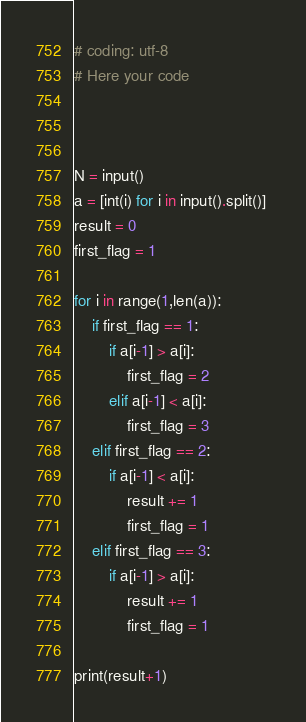Convert code to text. <code><loc_0><loc_0><loc_500><loc_500><_Python_># coding: utf-8
# Here your code



N = input()
a = [int(i) for i in input().split()] 
result = 0
first_flag = 1

for i in range(1,len(a)):
    if first_flag == 1:
        if a[i-1] > a[i]:
            first_flag = 2
        elif a[i-1] < a[i]:
            first_flag = 3
    elif first_flag == 2:
        if a[i-1] < a[i]:
            result += 1
            first_flag = 1
    elif first_flag == 3:
        if a[i-1] > a[i]:
            result += 1
            first_flag = 1    

print(result+1)
</code> 